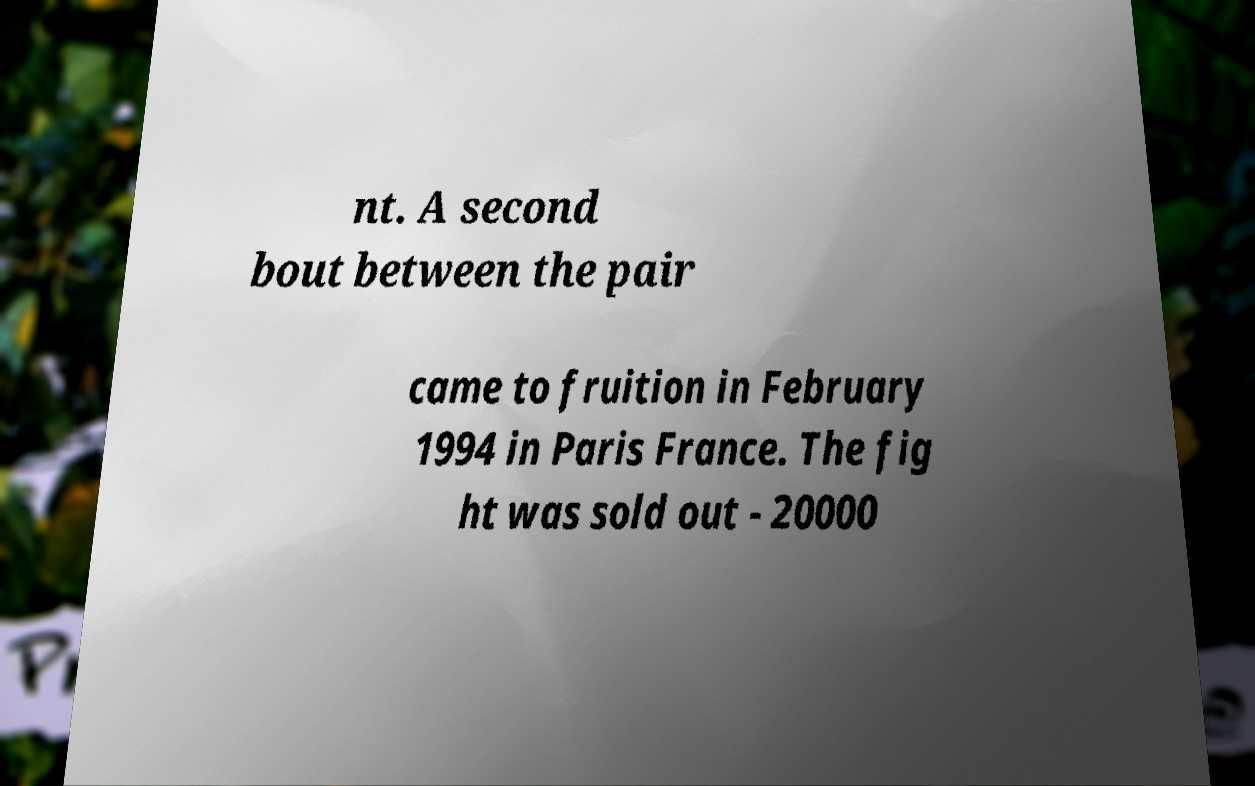There's text embedded in this image that I need extracted. Can you transcribe it verbatim? nt. A second bout between the pair came to fruition in February 1994 in Paris France. The fig ht was sold out - 20000 